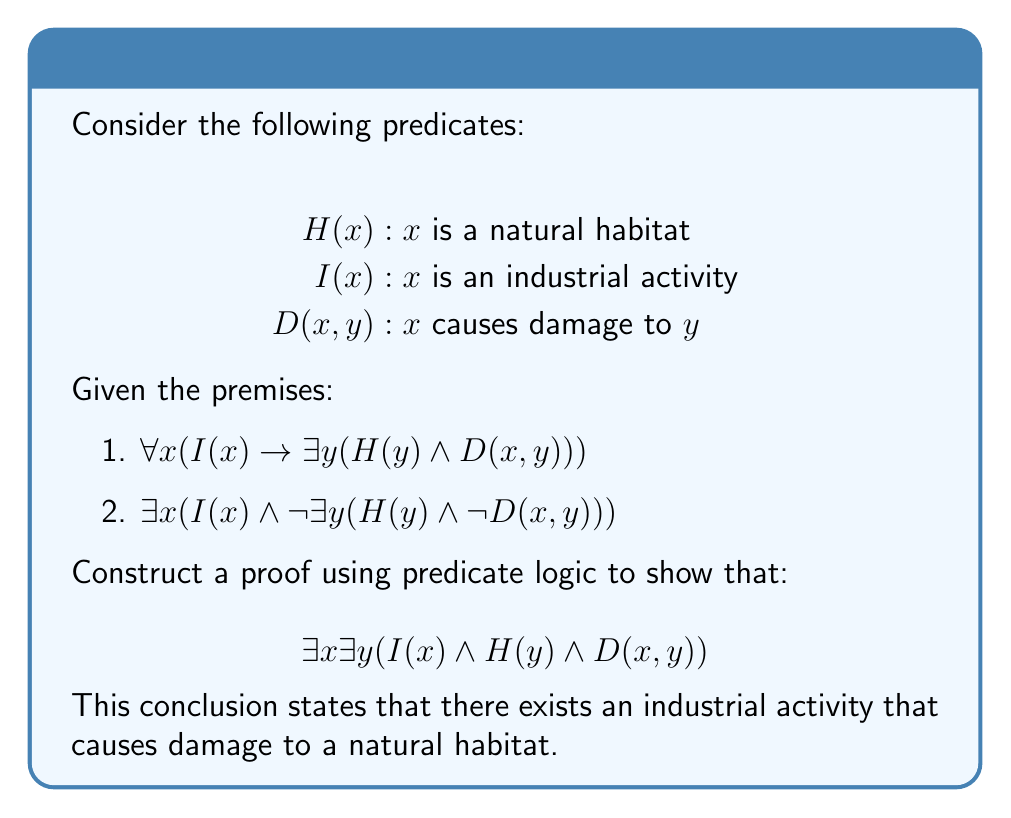Can you solve this math problem? Let's approach this proof step-by-step using predicate logic:

1) We start with premise 2: $\exists x (I(x) \wedge \neg \exists y (H(y) \wedge \neg D(x, y)))$

2) Let's assume this exists for some specific $a$:
   $I(a) \wedge \neg \exists y (H(y) \wedge \neg D(a, y))$

3) We can split this conjunction:
   $I(a)$ and $\neg \exists y (H(y) \wedge \neg D(a, y))$

4) The second part, $\neg \exists y (H(y) \wedge \neg D(a, y))$, is equivalent to:
   $\forall y \neg(H(y) \wedge \neg D(a, y))$

5) Using De Morgan's law, this is equivalent to:
   $\forall y (\neg H(y) \vee D(a, y))$

6) Now, let's use premise 1 with $x = a$:
   $I(a) \rightarrow \exists y (H(y) \wedge D(a, y))$

7) Since we know $I(a)$ from step 3, we can use modus ponens to conclude:
   $\exists y (H(y) \wedge D(a, y))$

8) Let's assume this exists for some specific $b$:
   $H(b) \wedge D(a, b)$

9) We now have:
   $I(a) \wedge H(b) \wedge D(a, b)$

10) This directly implies:
    $\exists x \exists y (I(x) \wedge H(y) \wedge D(x, y))$

Thus, we have proven the conclusion using the given premises and predicate logic.
Answer: $\exists x \exists y (I(x) \wedge H(y) \wedge D(x, y))$ 